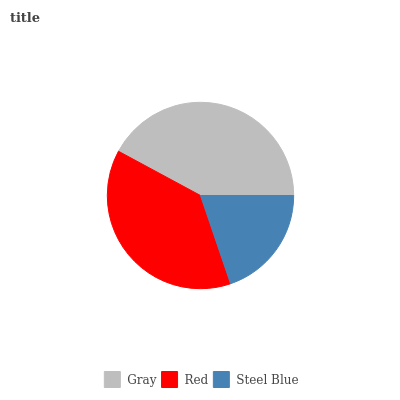Is Steel Blue the minimum?
Answer yes or no. Yes. Is Gray the maximum?
Answer yes or no. Yes. Is Red the minimum?
Answer yes or no. No. Is Red the maximum?
Answer yes or no. No. Is Gray greater than Red?
Answer yes or no. Yes. Is Red less than Gray?
Answer yes or no. Yes. Is Red greater than Gray?
Answer yes or no. No. Is Gray less than Red?
Answer yes or no. No. Is Red the high median?
Answer yes or no. Yes. Is Red the low median?
Answer yes or no. Yes. Is Gray the high median?
Answer yes or no. No. Is Gray the low median?
Answer yes or no. No. 